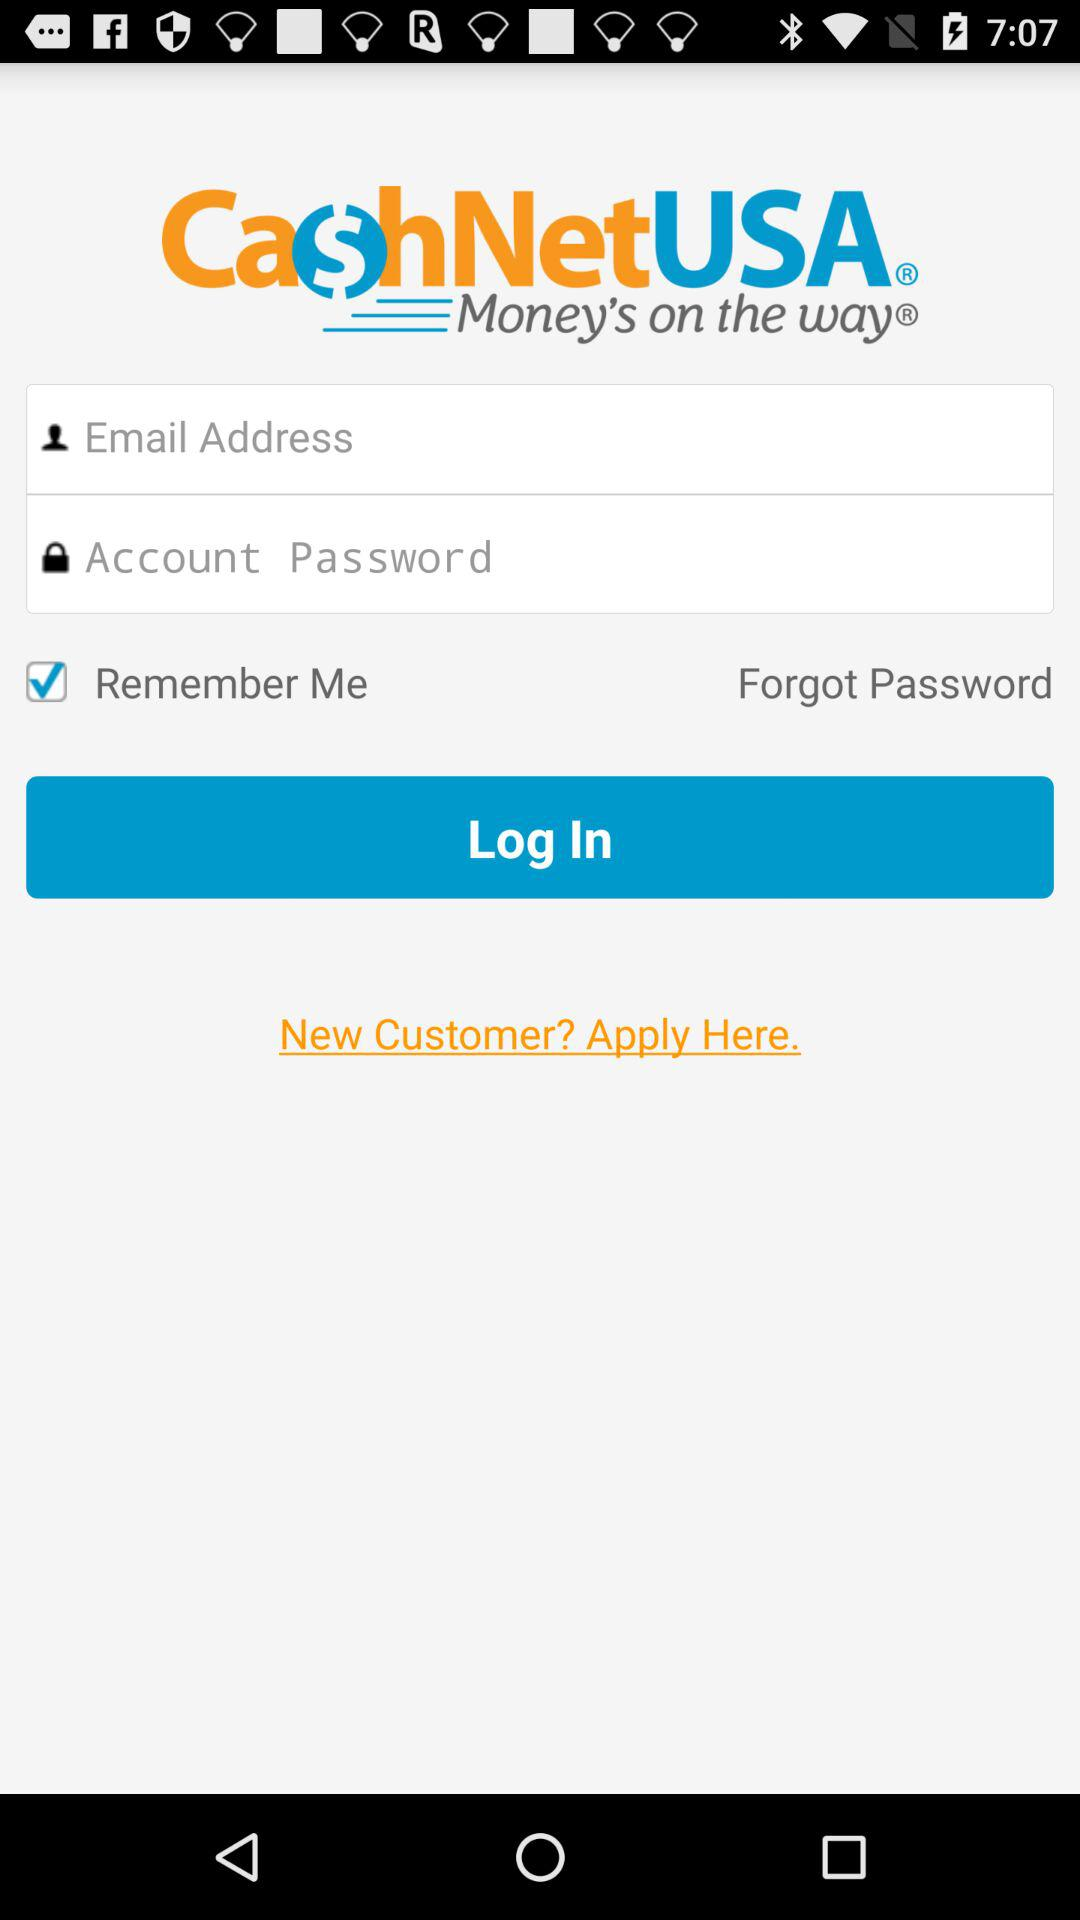What is the status of the "Remember Me" setting? The status is "on". 